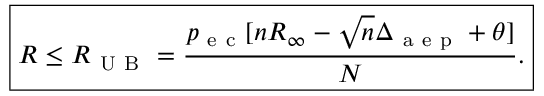Convert formula to latex. <formula><loc_0><loc_0><loc_500><loc_500>\boxed { R \leq R _ { U B } = \frac { p _ { e c } [ n R _ { \infty } - \sqrt { n } \Delta _ { a e p } + \theta ] } { N } . }</formula> 